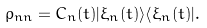<formula> <loc_0><loc_0><loc_500><loc_500>\rho _ { n n } = C _ { n } ( t ) | \xi _ { n } ( t ) \rangle \langle \xi _ { n } ( t ) | .</formula> 